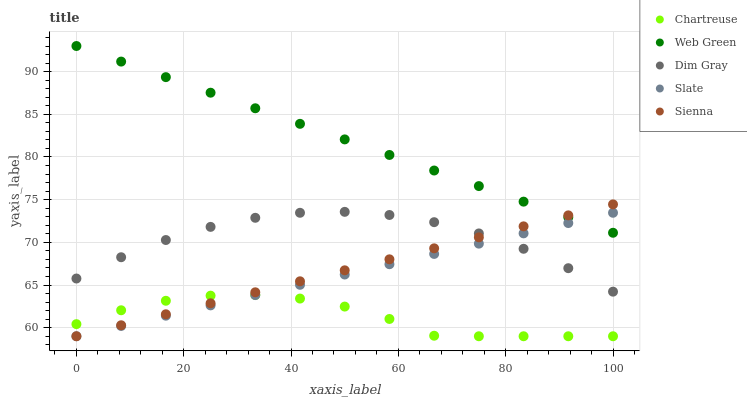Does Chartreuse have the minimum area under the curve?
Answer yes or no. Yes. Does Web Green have the maximum area under the curve?
Answer yes or no. Yes. Does Dim Gray have the minimum area under the curve?
Answer yes or no. No. Does Dim Gray have the maximum area under the curve?
Answer yes or no. No. Is Sienna the smoothest?
Answer yes or no. Yes. Is Chartreuse the roughest?
Answer yes or no. Yes. Is Dim Gray the smoothest?
Answer yes or no. No. Is Dim Gray the roughest?
Answer yes or no. No. Does Sienna have the lowest value?
Answer yes or no. Yes. Does Dim Gray have the lowest value?
Answer yes or no. No. Does Web Green have the highest value?
Answer yes or no. Yes. Does Dim Gray have the highest value?
Answer yes or no. No. Is Chartreuse less than Web Green?
Answer yes or no. Yes. Is Dim Gray greater than Chartreuse?
Answer yes or no. Yes. Does Web Green intersect Slate?
Answer yes or no. Yes. Is Web Green less than Slate?
Answer yes or no. No. Is Web Green greater than Slate?
Answer yes or no. No. Does Chartreuse intersect Web Green?
Answer yes or no. No. 